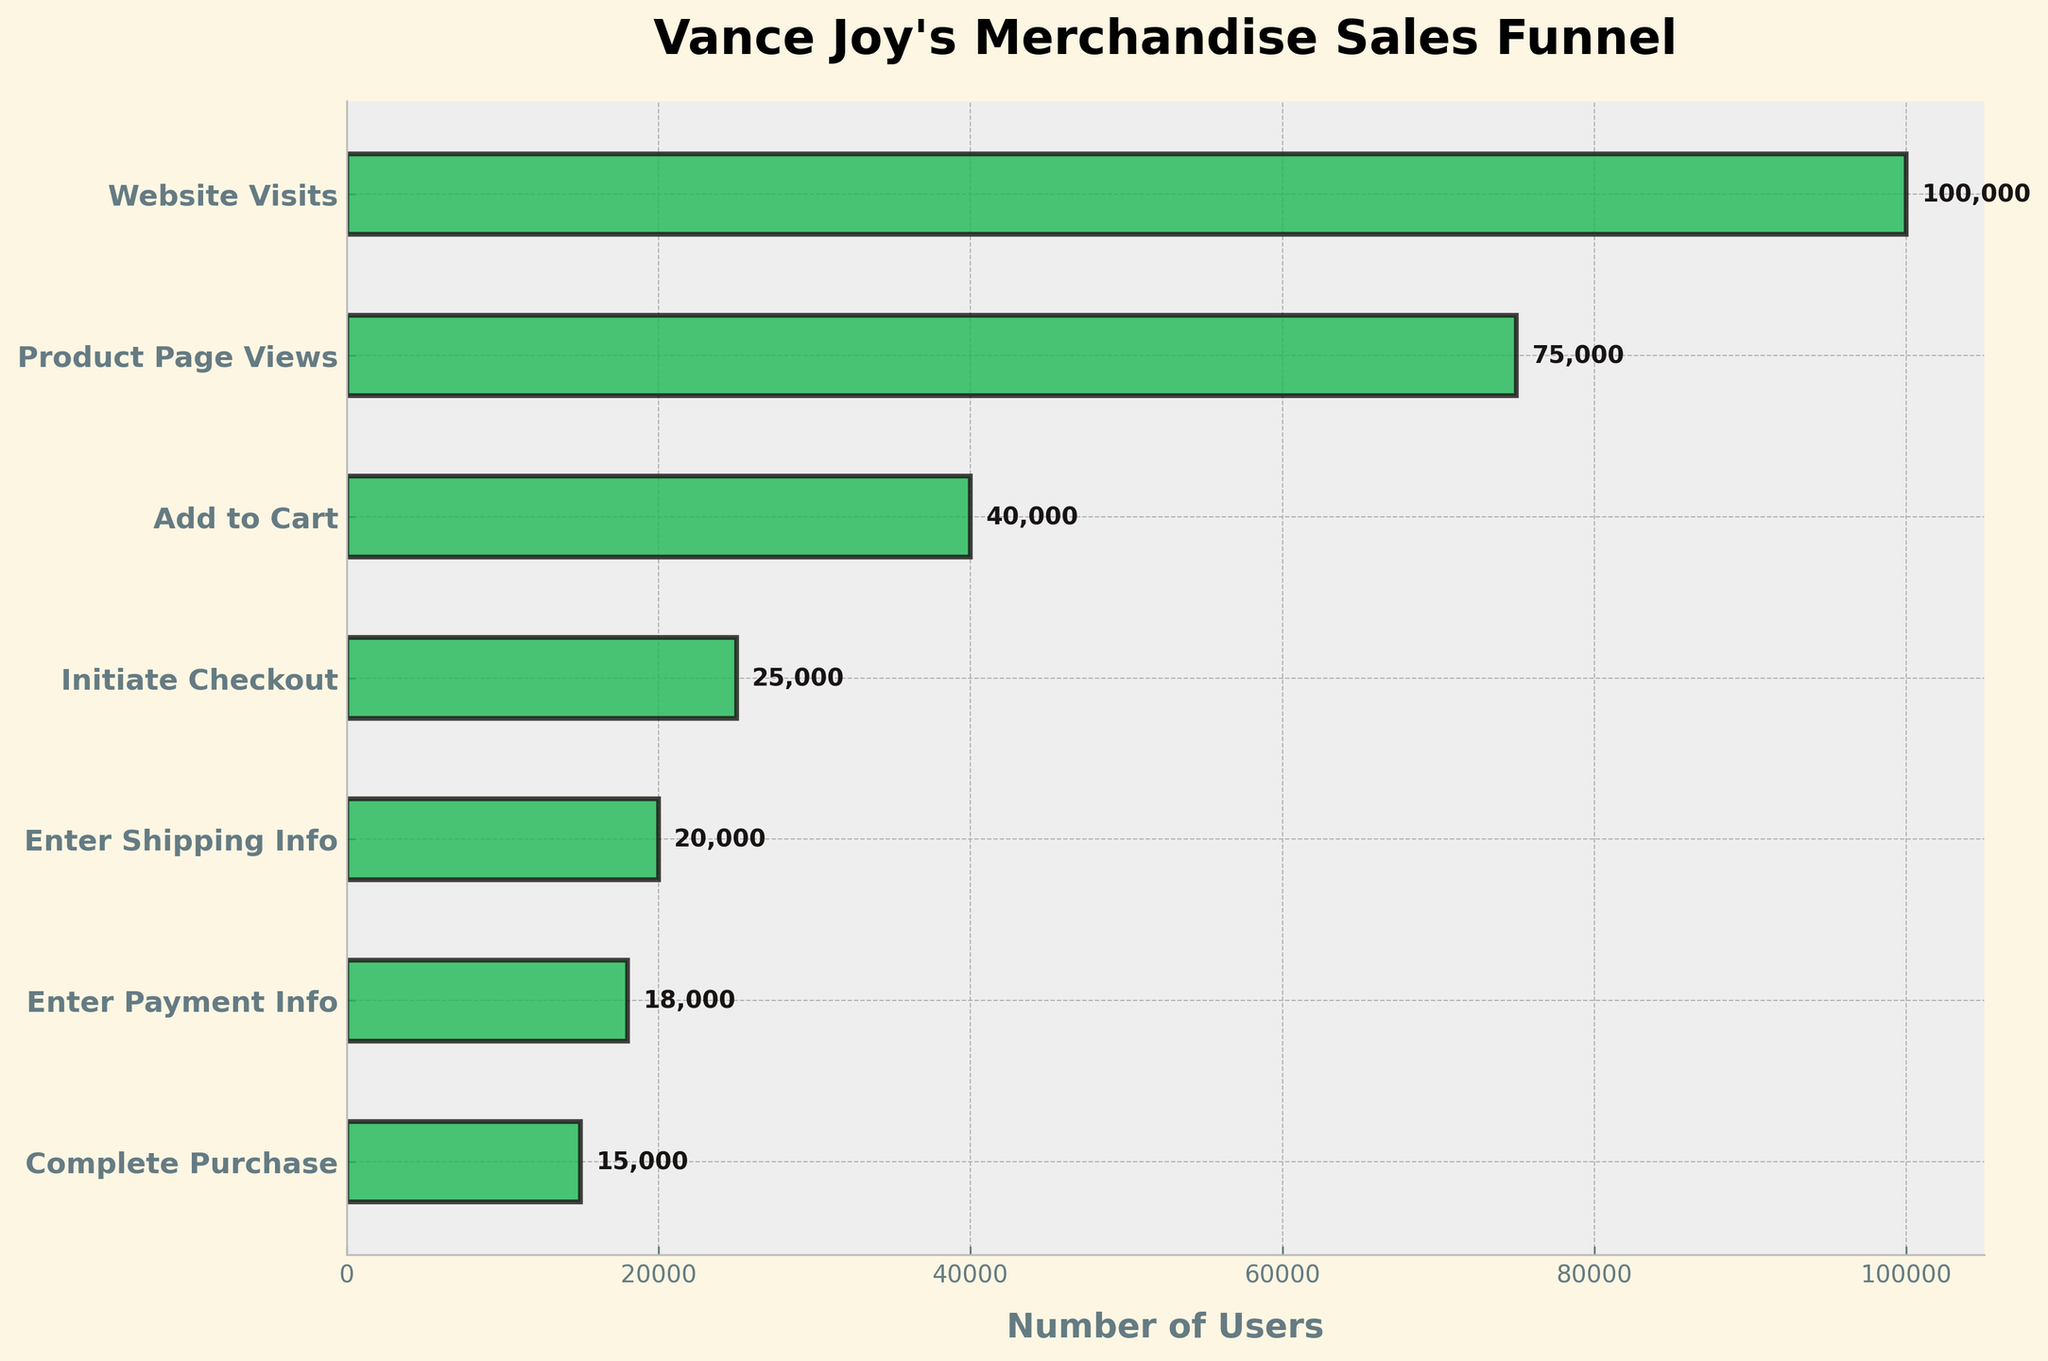How many users completed the purchase? From the funnel chart, locate the stage "Complete Purchase" and read the corresponding number of users.
Answer: 15,000 What is the title of the funnel chart? Look at the top of the chart where the title is usually placed.
Answer: Vance Joy's Merchandise Sales Funnel Which stage has the most significant drop-off in users? Compare the number of users between each stage and identify the largest difference. The largest drop-off is between "Product Page Views" and "Add to Cart" which is 75,000 - 40,000.
Answer: Product Page Views to Add to Cart What is the average number of users from the "Add to Cart" stage to the "Complete Purchase" stage? Calculate the sum of users in each stage from "Add to Cart" (40,000), "Initiate Checkout" (25,000), "Enter Shipping Info" (20,000), "Enter Payment Info" (18,000), and "Complete Purchase" (15,000), then divide by the number of stages, which is 5. (40,000 + 25,000 + 20,000 + 18,000 + 15,000) / 5 = 23,600 users on average.
Answer: 23,600 How does the number of users entering shipping info compare to the number of users initiating checkout? Subtract the number of users in "Enter Shipping Info" from "Initiate Checkout" (25,000 - 20,000).
Answer: 5,000 fewer What percentage of users who visit the website complete the purchase? To find the percentage, divide the number of users who complete the purchase (15,000) by the number of users who visit the website (100,000) and multiply by 100. (15,000 / 100,000) * 100 = 15%.
Answer: 15% How many fewer users enter payment info than enter shipping info? Subtract the number of users in "Enter Payment Info" from "Enter Shipping Info" (20,000 - 18,000).
Answer: 2,000 fewer Which stage has the second highest number of users? List the number of users in each stage and find the second highest number. The highest is 100,000 in "Website Visits", and the second highest is 75,000 in "Product Page Views".
Answer: Product Page Views What is the gap between the users who initiate checkout and users who complete purchase? Subtract the number of users who complete the purchase (15,000) from those who initiate checkout (25,000). (25,000 - 15,000)
Answer: 10,000 